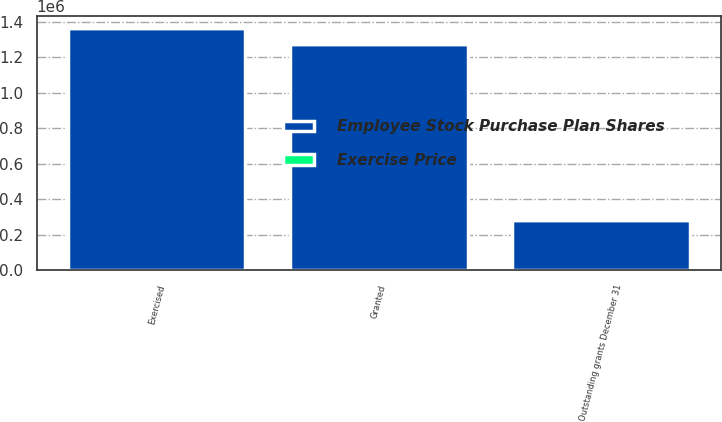Convert chart to OTSL. <chart><loc_0><loc_0><loc_500><loc_500><stacked_bar_chart><ecel><fcel>Outstanding grants December 31<fcel>Granted<fcel>Exercised<nl><fcel>Employee Stock Purchase Plan Shares<fcel>283400<fcel>1.27304e+06<fcel>1.3622e+06<nl><fcel>Exercise Price<fcel>62.55<fcel>55.51<fcel>51.5<nl></chart> 